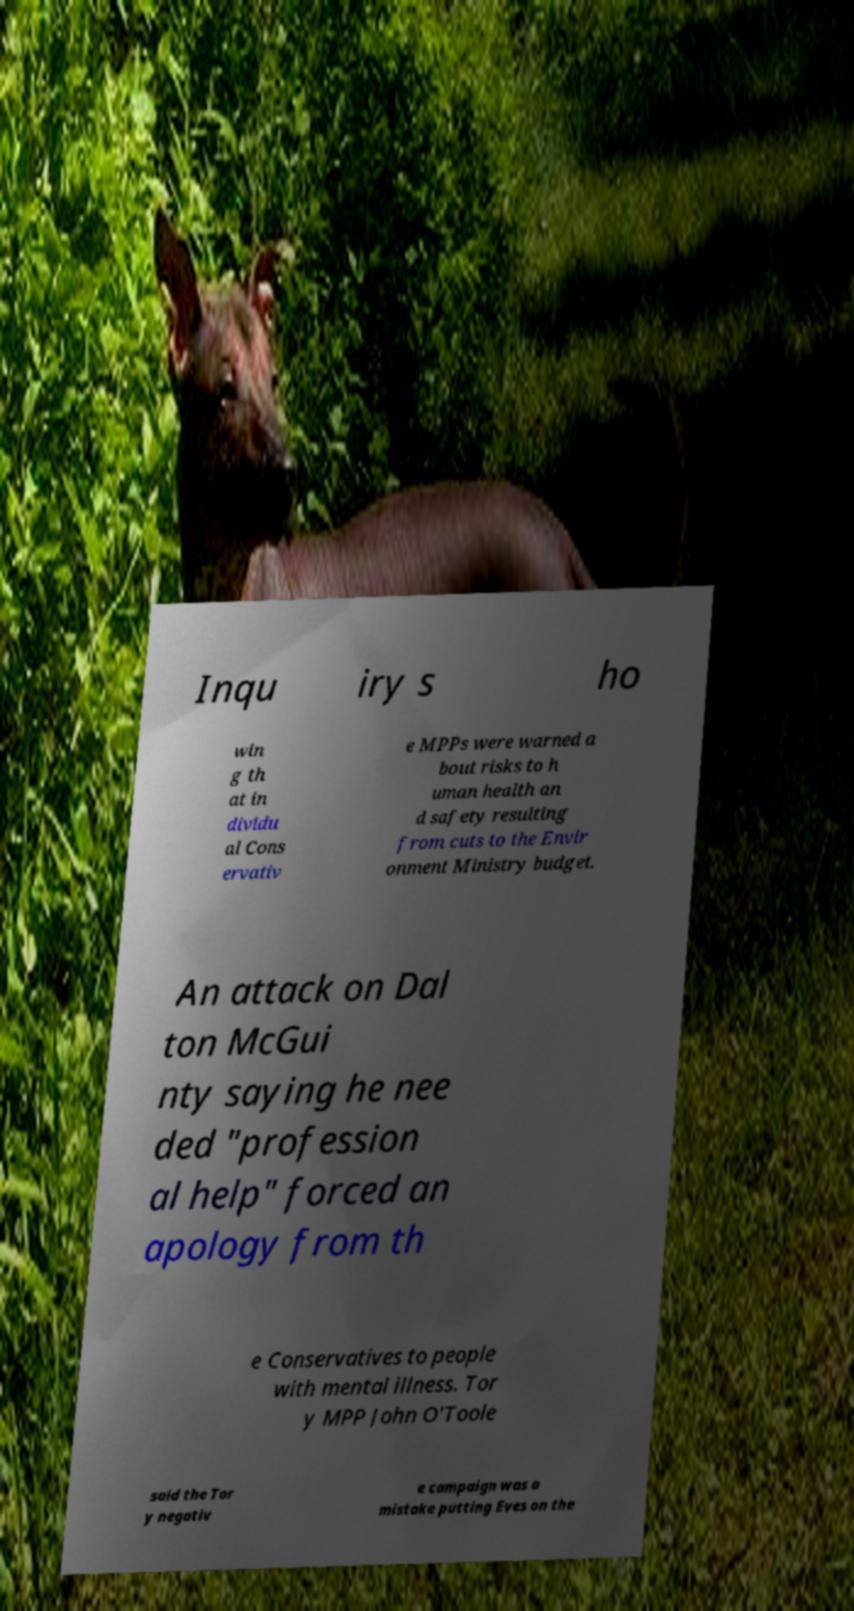There's text embedded in this image that I need extracted. Can you transcribe it verbatim? Inqu iry s ho win g th at in dividu al Cons ervativ e MPPs were warned a bout risks to h uman health an d safety resulting from cuts to the Envir onment Ministry budget. An attack on Dal ton McGui nty saying he nee ded "profession al help" forced an apology from th e Conservatives to people with mental illness. Tor y MPP John O'Toole said the Tor y negativ e campaign was a mistake putting Eves on the 